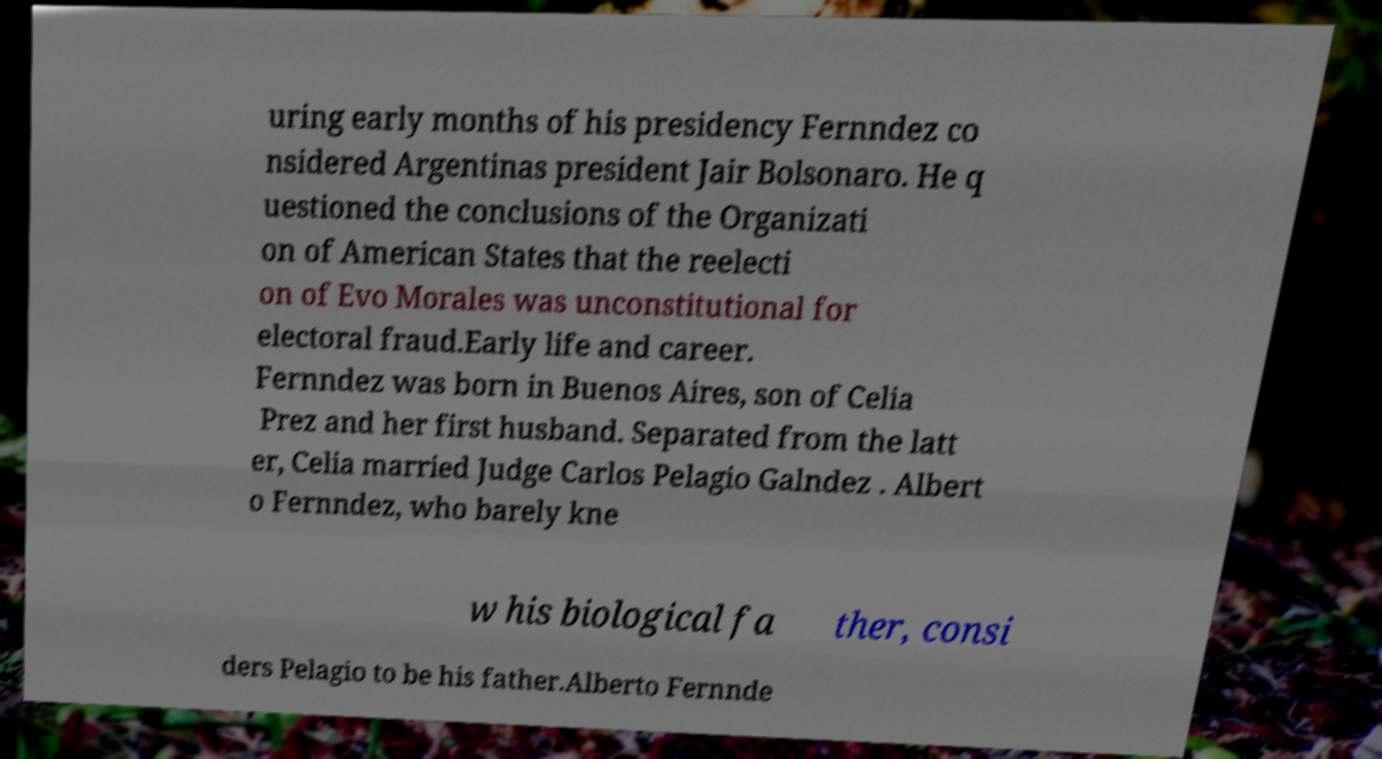What messages or text are displayed in this image? I need them in a readable, typed format. uring early months of his presidency Fernndez co nsidered Argentinas president Jair Bolsonaro. He q uestioned the conclusions of the Organizati on of American States that the reelecti on of Evo Morales was unconstitutional for electoral fraud.Early life and career. Fernndez was born in Buenos Aires, son of Celia Prez and her first husband. Separated from the latt er, Celia married Judge Carlos Pelagio Galndez . Albert o Fernndez, who barely kne w his biological fa ther, consi ders Pelagio to be his father.Alberto Fernnde 